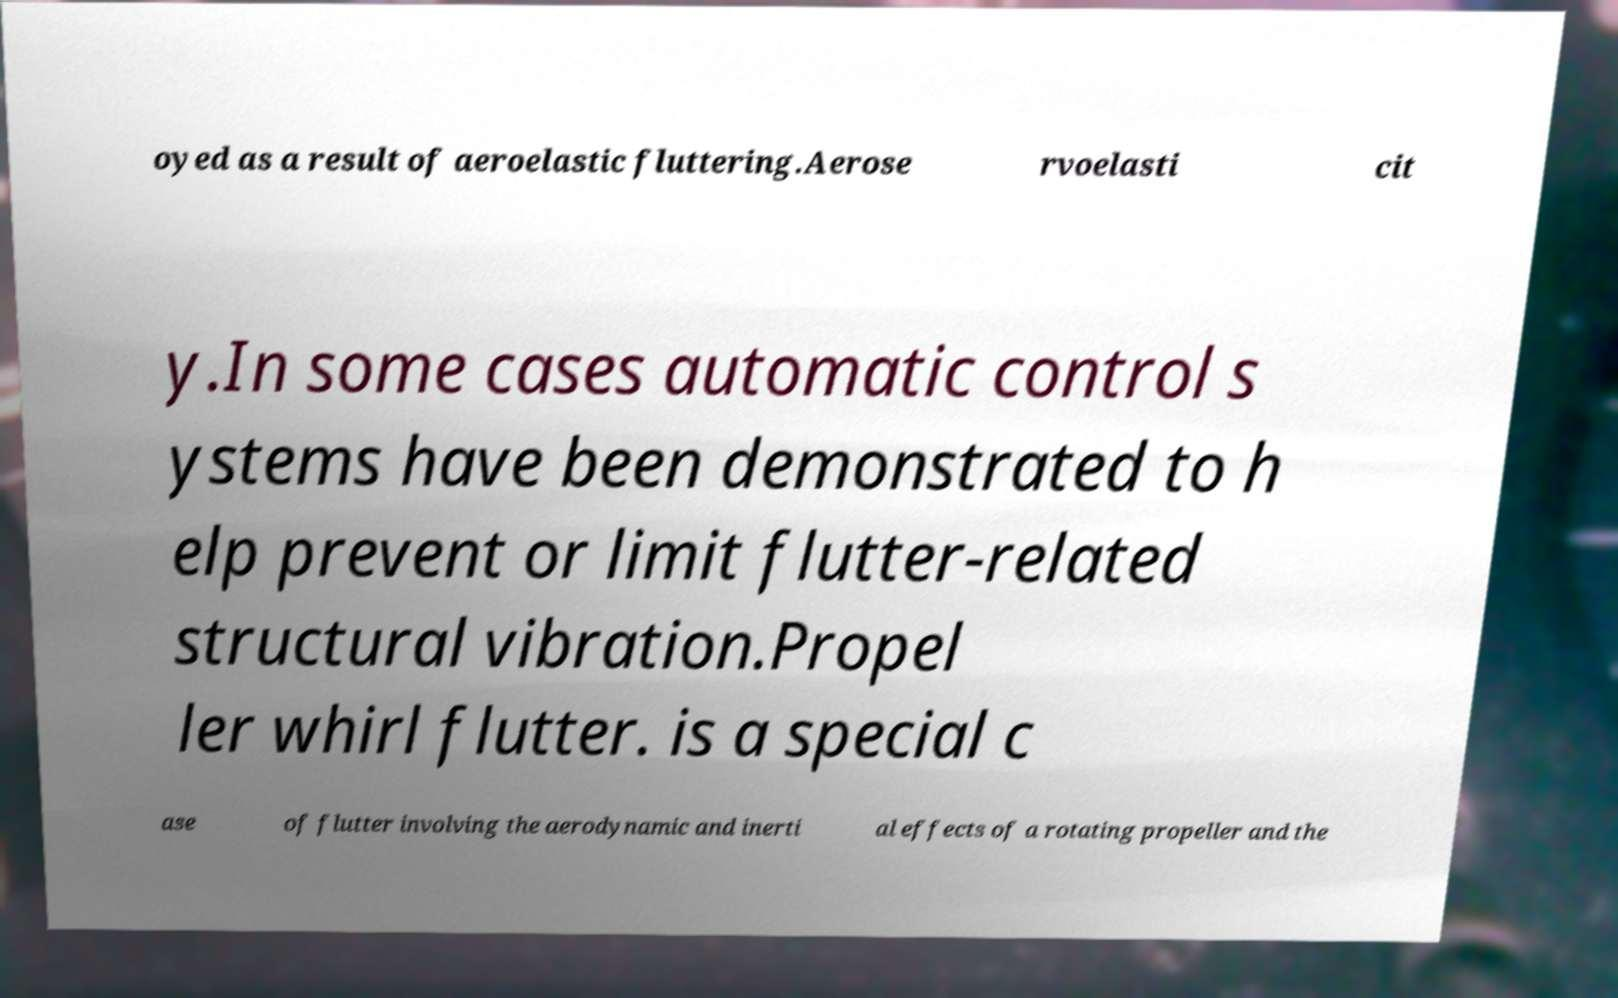Can you accurately transcribe the text from the provided image for me? oyed as a result of aeroelastic fluttering.Aerose rvoelasti cit y.In some cases automatic control s ystems have been demonstrated to h elp prevent or limit flutter-related structural vibration.Propel ler whirl flutter. is a special c ase of flutter involving the aerodynamic and inerti al effects of a rotating propeller and the 